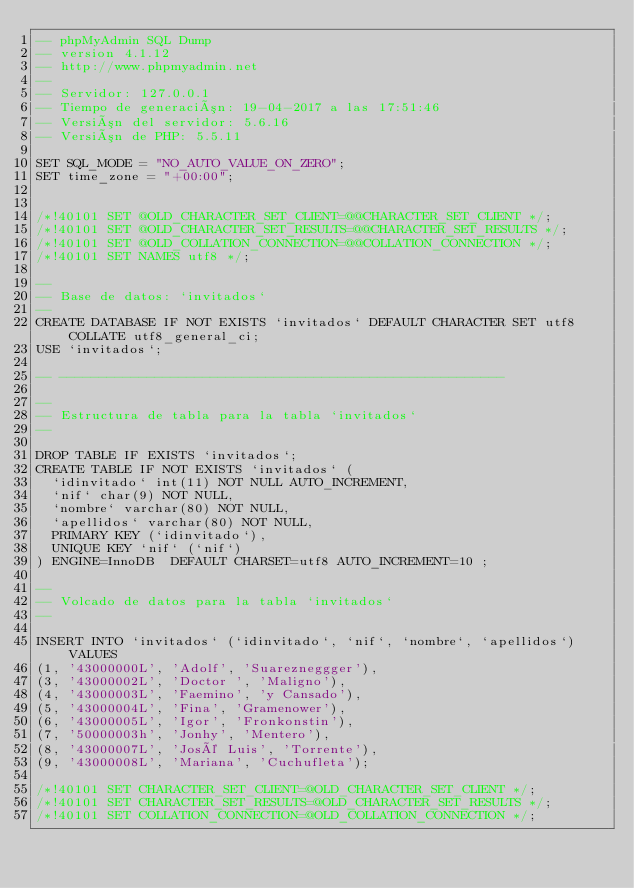Convert code to text. <code><loc_0><loc_0><loc_500><loc_500><_SQL_>-- phpMyAdmin SQL Dump
-- version 4.1.12
-- http://www.phpmyadmin.net
--
-- Servidor: 127.0.0.1
-- Tiempo de generación: 19-04-2017 a las 17:51:46
-- Versión del servidor: 5.6.16
-- Versión de PHP: 5.5.11

SET SQL_MODE = "NO_AUTO_VALUE_ON_ZERO";
SET time_zone = "+00:00";


/*!40101 SET @OLD_CHARACTER_SET_CLIENT=@@CHARACTER_SET_CLIENT */;
/*!40101 SET @OLD_CHARACTER_SET_RESULTS=@@CHARACTER_SET_RESULTS */;
/*!40101 SET @OLD_COLLATION_CONNECTION=@@COLLATION_CONNECTION */;
/*!40101 SET NAMES utf8 */;

--
-- Base de datos: `invitados`
--
CREATE DATABASE IF NOT EXISTS `invitados` DEFAULT CHARACTER SET utf8 COLLATE utf8_general_ci;
USE `invitados`;

-- --------------------------------------------------------

--
-- Estructura de tabla para la tabla `invitados`
--

DROP TABLE IF EXISTS `invitados`;
CREATE TABLE IF NOT EXISTS `invitados` (
  `idinvitado` int(11) NOT NULL AUTO_INCREMENT,
  `nif` char(9) NOT NULL,
  `nombre` varchar(80) NOT NULL,
  `apellidos` varchar(80) NOT NULL,
  PRIMARY KEY (`idinvitado`),
  UNIQUE KEY `nif` (`nif`)
) ENGINE=InnoDB  DEFAULT CHARSET=utf8 AUTO_INCREMENT=10 ;

--
-- Volcado de datos para la tabla `invitados`
--

INSERT INTO `invitados` (`idinvitado`, `nif`, `nombre`, `apellidos`) VALUES
(1, '43000000L', 'Adolf', 'Suarezneggger'),
(3, '43000002L', 'Doctor ', 'Maligno'),
(4, '43000003L', 'Faemino', 'y Cansado'),
(5, '43000004L', 'Fina', 'Gramenower'),
(6, '43000005L', 'Igor', 'Fronkonstin'),
(7, '50000003h', 'Jonhy', 'Mentero'),
(8, '43000007L', 'José Luis', 'Torrente'),
(9, '43000008L', 'Mariana', 'Cuchufleta');

/*!40101 SET CHARACTER_SET_CLIENT=@OLD_CHARACTER_SET_CLIENT */;
/*!40101 SET CHARACTER_SET_RESULTS=@OLD_CHARACTER_SET_RESULTS */;
/*!40101 SET COLLATION_CONNECTION=@OLD_COLLATION_CONNECTION */;
</code> 